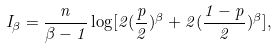Convert formula to latex. <formula><loc_0><loc_0><loc_500><loc_500>I _ { \beta } = \frac { n } { \beta - 1 } \log [ 2 ( \frac { p } { 2 } ) ^ { \beta } + 2 ( \frac { 1 - p } { 2 } ) ^ { \beta } ] ,</formula> 